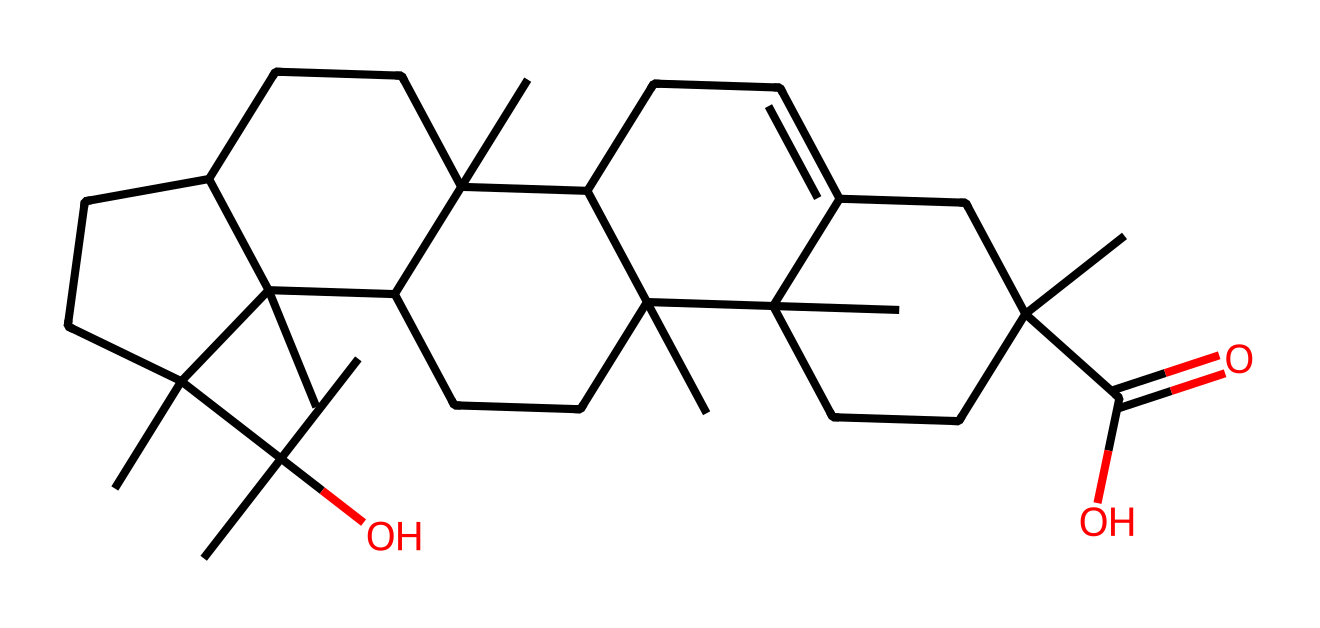What is the molecular formula of this compound? To determine the molecular formula, we can analyze the chemical structure represented by the SMILES notation. By counting the number of each type of atom included in the structure, we find that the compound consists of 15 carbons (C), 24 hydrogens (H), and 2 oxygens (O), leading to the molecular formula C15H24O2.
Answer: C15H24O2 How many rings are present in this chemical structure? By examining the SMILES representation, we note the presence of multiple occurrences of numbers, which indicate the start and end of rings. Specifically, we identify three ring closures in this structure, thus confirming that there are 3 rings in total.
Answer: 3 What is the primary functional group in this compound? The molecular structure includes a carboxylic acid functional group, identifiable by the –COOH portion at the beginning of the SMILES. This functional group is indicative of the acid characteristics of the compound.
Answer: carboxylic acid What type of chemical compound is this? Considering the functional group and overall structure, we can classify this chemical as a terpenoid, which is a type of natural organic compound derived from terpenes. The complexity of its structure and presence of rings further supports this classification.
Answer: terpenoid Does this compound contain any double bonds? The chemical structure, when analyzed through the SMILES representation, shows several points where the carbon atoms are connected using double bonds, specifically within the cyclic portions of the molecule. Hence, we conclude that double bonds are indeed present.
Answer: yes What is a potential use of this chemical in cosmetics? Given that this compound belongs to the class of terpenoids and has properties linked to aromatic fragrances and soothing effects, it can be utilized in cosmetics for its scent and potential skin benefits, especially in formulations that aim for a sensory experience, like perfumes and creams.
Answer: fragrance 